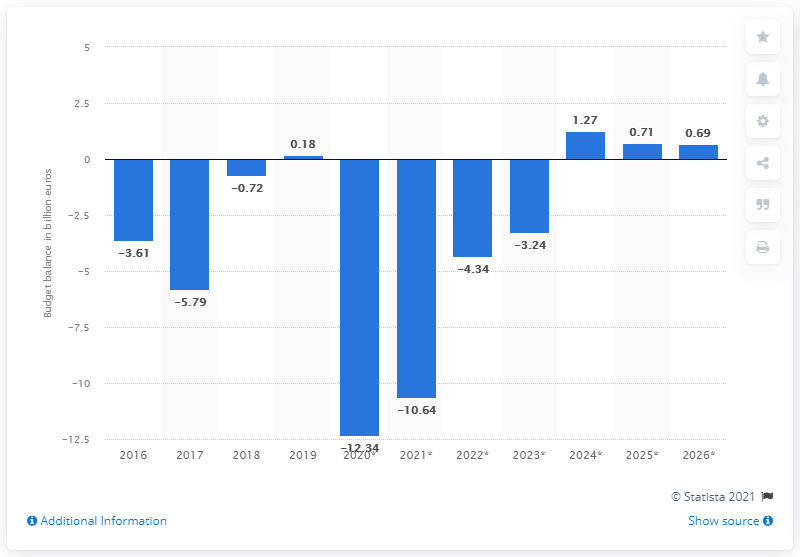Give some essential details in this illustration. The state surplus of Portugal in 2019 was 0.18. 